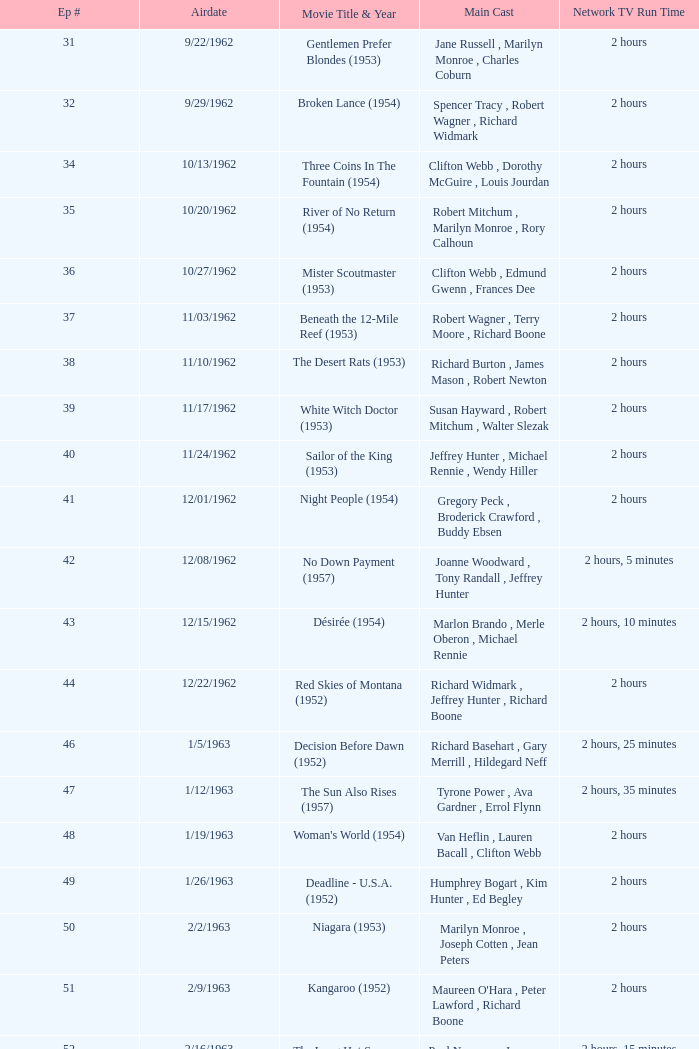Who was the cast on the 3/23/1963 episode? Dana Wynter , Mel Ferrer , Theodore Bikel. 